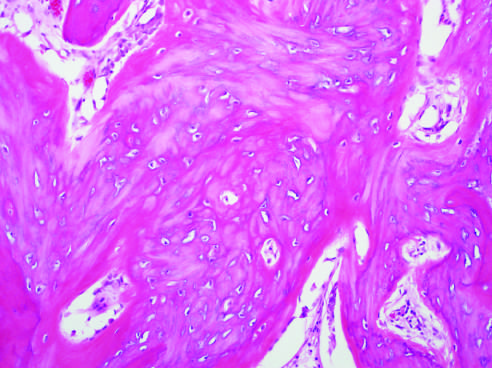s this more cellular and disorganized than fig.654?
Answer the question using a single word or phrase. Yes 